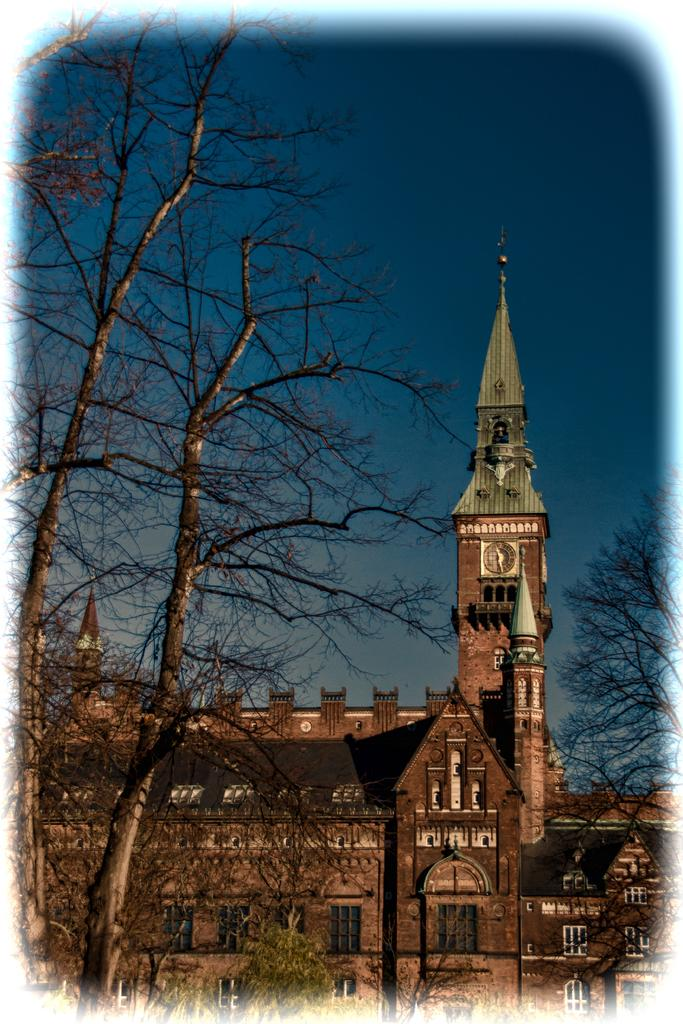What type of vegetation is visible in the front of the image? There are trees in the front of the image. What type of structures can be seen in the background of the image? There are buildings in the background of the image, including a clock tower. What is the condition of the sky in the image? The sky is cloudy in the image. What type of jelly is being used to caption the skirt in the image? There is no jelly, caption, or skirt present in the image. 